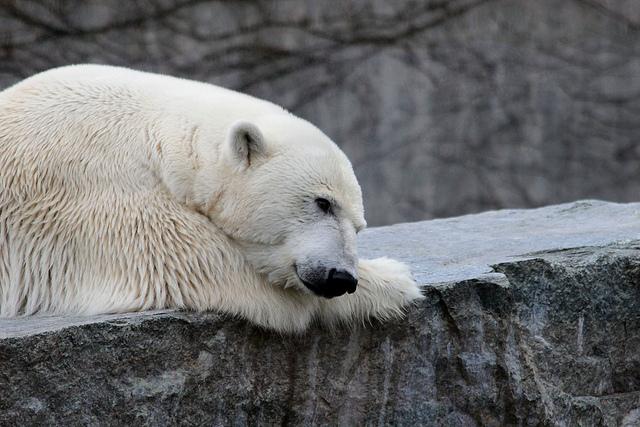Could a human being pick this animal up in their hands?
Concise answer only. No. Does the animal appear to be agitated?
Write a very short answer. No. What animal is this?
Write a very short answer. Polar bear. 